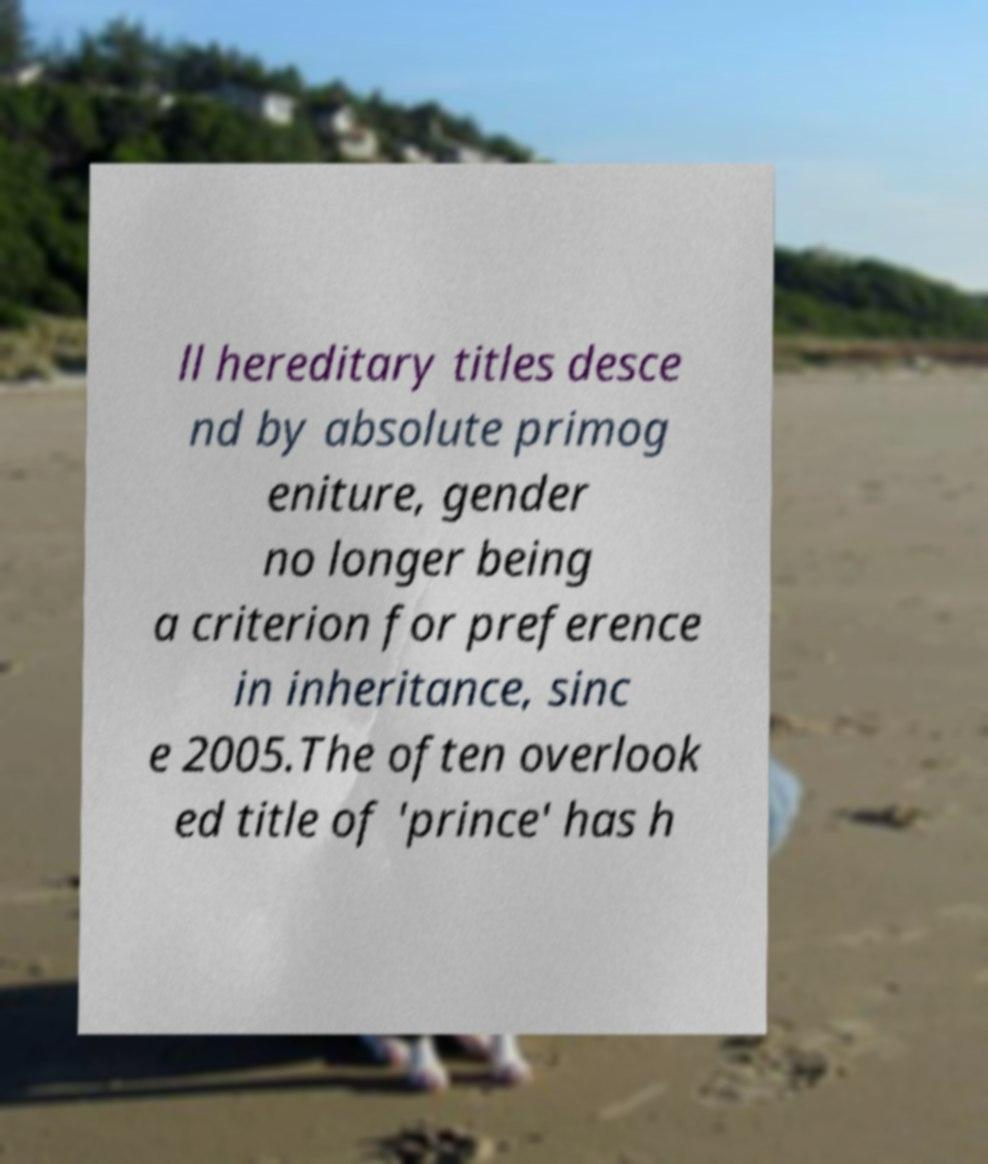Can you accurately transcribe the text from the provided image for me? ll hereditary titles desce nd by absolute primog eniture, gender no longer being a criterion for preference in inheritance, sinc e 2005.The often overlook ed title of 'prince' has h 